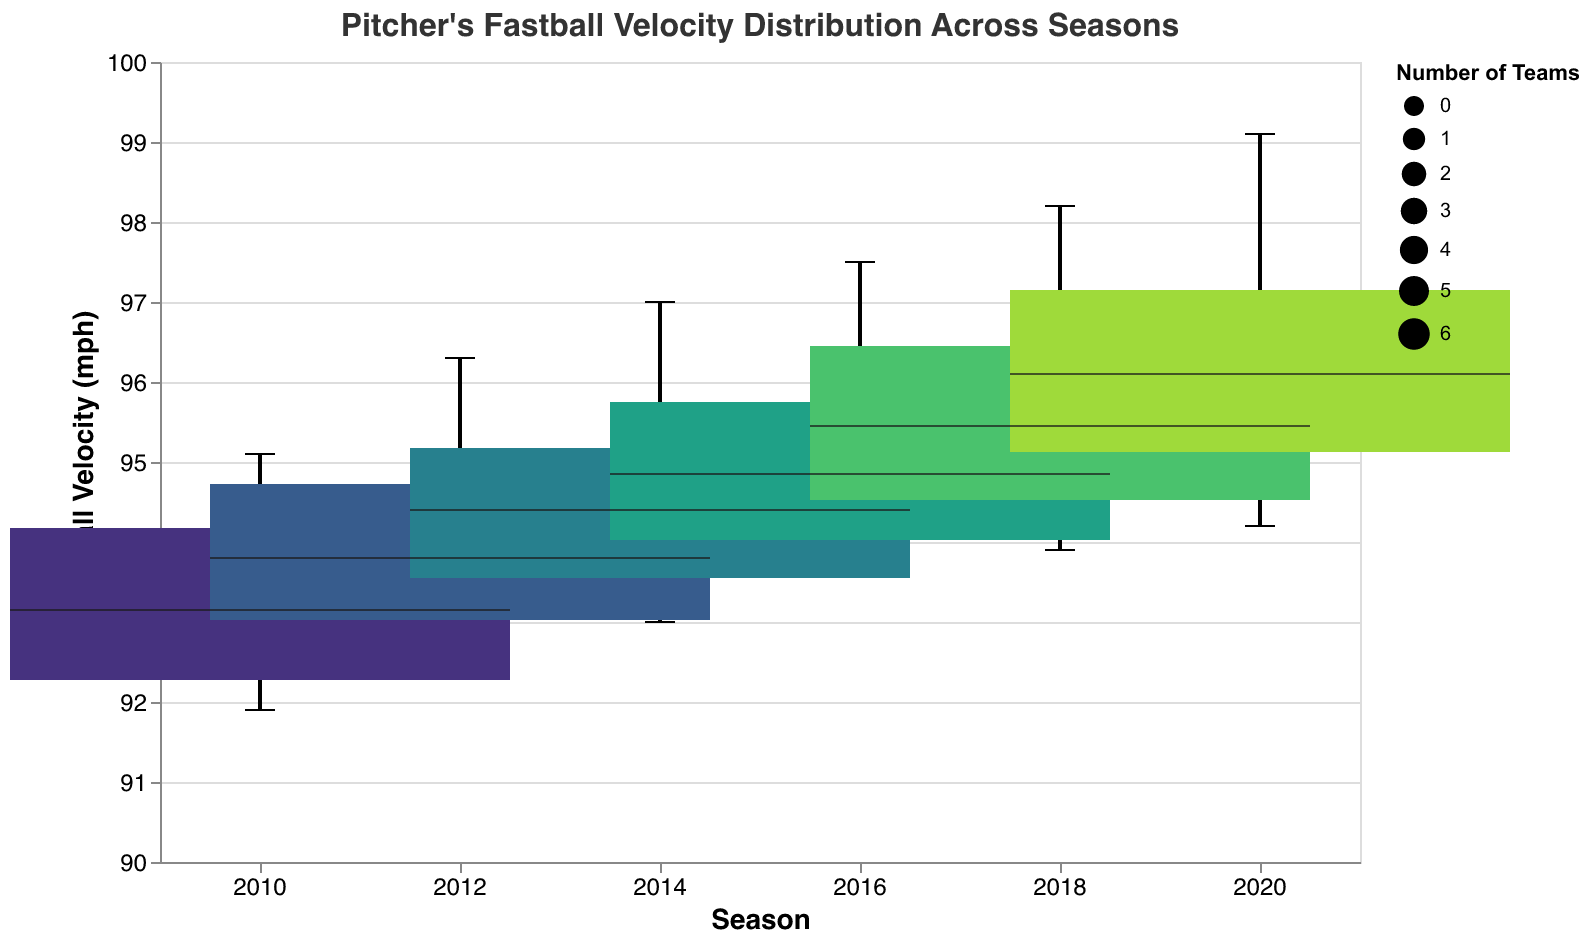What's the title of the figure? Look at the top of the figure where the title is displayed.
Answer: Pitcher's Fastball Velocity Distribution Across Seasons Which season has the highest median fastball velocity? Compare the median lines in the boxes for each season. The median line is typically indicated by a bold horizontal line inside the box.
Answer: 2020 Which team had the lowest fastball velocity in 2018? Identify the smallest value within the box and whisker plot for the 2018 season.
Answer: San Francisco Giants What is the range of fastball velocities for the 2016 season? Find the minimum and maximum values from the whiskers of the 2016 box plot.
Answer: 93.6 to 97.5 mph How does the fastball velocity of New York Yankees in 2010 compare to 2020? Locate the New York Yankees' data points for 2010 and 2020 and compare their positions.
Answer: Increased from 95.1 mph to 99.1 mph What is the interquartile range (IQR) for the 2014 season's fastball velocities? The IQR is the difference between the 75th percentile (upper edge of the box) and the 25th percentile (lower edge of the box) for the 2014 season.
Answer: 93.5 to 95.2 mph Which season has the smallest variability in fastball velocity among the teams? Variability can be assessed by the size of the box and length of whiskers. The season with the smallest box and shortest whiskers will have the least variability.
Answer: 2010 Is there a trend in the median fastball velocities from 2010 to 2020? Observe the median lines across the seasons from left to right to identify any upward or downward trend.
Answer: Increasing How many teams are represented in each season? Look at the width of the boxes; the size encoding reflects the number of teams, which should be consistent since the data listed 6 teams per season.
Answer: 6 teams 